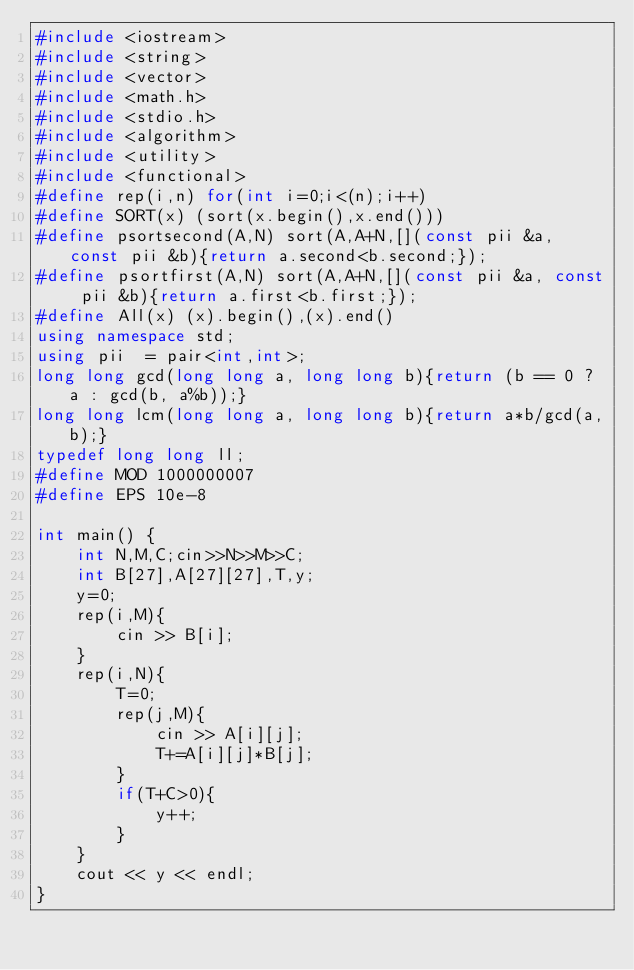<code> <loc_0><loc_0><loc_500><loc_500><_C++_>#include <iostream>
#include <string>
#include <vector>
#include <math.h>
#include <stdio.h>
#include <algorithm>
#include <utility>
#include <functional>
#define rep(i,n) for(int i=0;i<(n);i++)
#define SORT(x) (sort(x.begin(),x.end()))
#define psortsecond(A,N) sort(A,A+N,[](const pii &a, const pii &b){return a.second<b.second;});
#define psortfirst(A,N) sort(A,A+N,[](const pii &a, const pii &b){return a.first<b.first;});
#define All(x) (x).begin(),(x).end()
using namespace std;
using pii  = pair<int,int>;
long long gcd(long long a, long long b){return (b == 0 ? a : gcd(b, a%b));}
long long lcm(long long a, long long b){return a*b/gcd(a,b);}
typedef long long ll;
#define MOD 1000000007
#define EPS 10e-8

int main() {
    int N,M,C;cin>>N>>M>>C;
    int B[27],A[27][27],T,y;
    y=0;
    rep(i,M){
        cin >> B[i];
    }
    rep(i,N){
        T=0;
        rep(j,M){
            cin >> A[i][j];
            T+=A[i][j]*B[j];
        }
        if(T+C>0){
            y++;
        }
    }
    cout << y << endl;
}</code> 